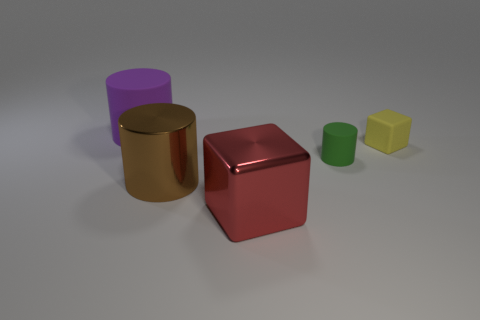Add 1 small yellow matte blocks. How many objects exist? 6 Subtract all cylinders. How many objects are left? 2 Subtract all small yellow blocks. Subtract all small green cylinders. How many objects are left? 3 Add 2 large purple things. How many large purple things are left? 3 Add 2 small yellow cylinders. How many small yellow cylinders exist? 2 Subtract 1 yellow cubes. How many objects are left? 4 